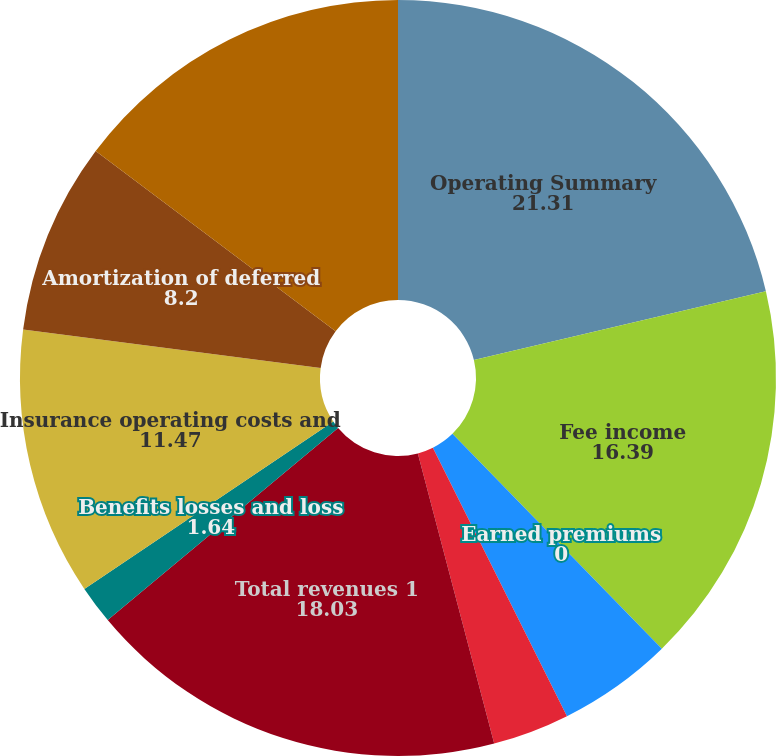Convert chart. <chart><loc_0><loc_0><loc_500><loc_500><pie_chart><fcel>Operating Summary<fcel>Fee income<fcel>Earned premiums<fcel>Net investment income<fcel>Net realized capital losses<fcel>Total revenues 1<fcel>Benefits losses and loss<fcel>Insurance operating costs and<fcel>Amortization of deferred<fcel>Total benefits losses and<nl><fcel>21.31%<fcel>16.39%<fcel>0.0%<fcel>4.92%<fcel>3.28%<fcel>18.03%<fcel>1.64%<fcel>11.47%<fcel>8.2%<fcel>14.75%<nl></chart> 